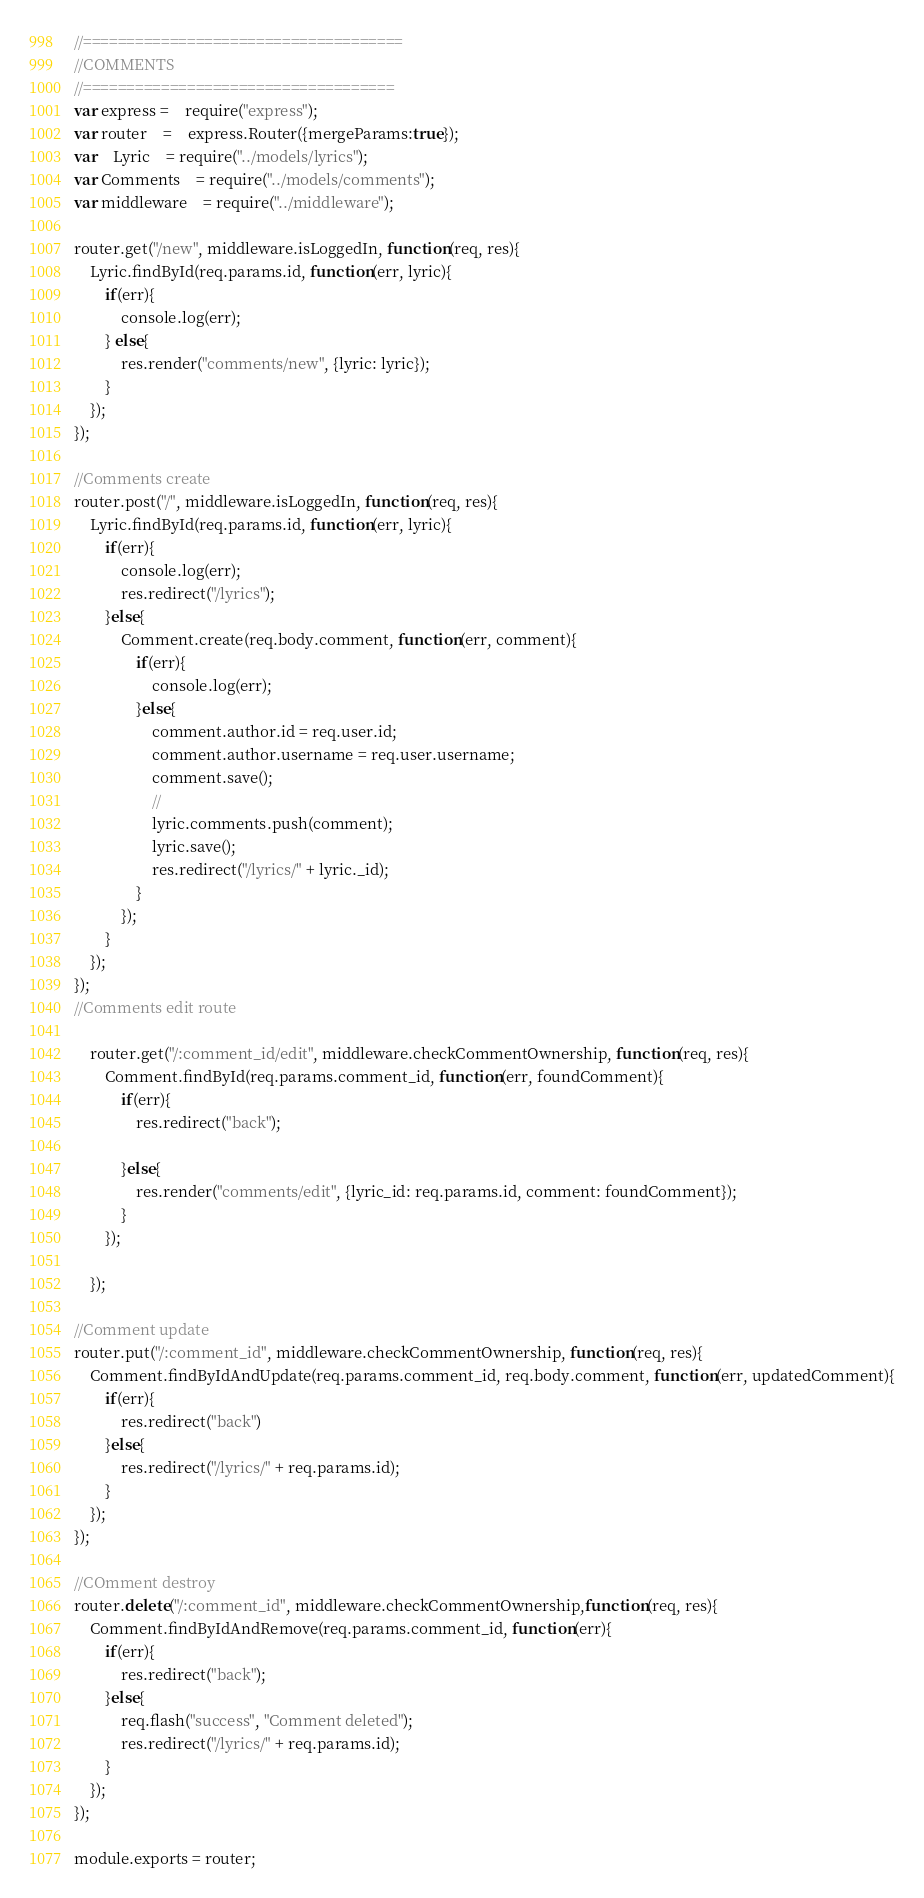<code> <loc_0><loc_0><loc_500><loc_500><_JavaScript_>//=====================================
//COMMENTS
//====================================
var express = 	require("express");
var router 	=	express.Router({mergeParams:true});
var	Lyric	= require("../models/lyrics");
var Comments 	= require("../models/comments");
var middleware	= require("../middleware");

router.get("/new", middleware.isLoggedIn, function(req, res){
	Lyric.findById(req.params.id, function(err, lyric){
		if(err){
			console.log(err);
		} else{
			res.render("comments/new", {lyric: lyric});
		}
	});
});

//Comments create
router.post("/", middleware.isLoggedIn, function(req, res){
	Lyric.findById(req.params.id, function(err, lyric){
		if(err){
			console.log(err);
			res.redirect("/lyrics");
		}else{
			Comment.create(req.body.comment, function(err, comment){
				if(err){
					console.log(err);
				}else{
					comment.author.id = req.user.id;
					comment.author.username = req.user.username;
					comment.save();
					//
					lyric.comments.push(comment);
					lyric.save();
					res.redirect("/lyrics/" + lyric._id);
				}
			});
		}
	});
});
//Comments edit route

	router.get("/:comment_id/edit", middleware.checkCommentOwnership, function(req, res){
		Comment.findById(req.params.comment_id, function(err, foundComment){
			if(err){
				res.redirect("back");

			}else{
				res.render("comments/edit", {lyric_id: req.params.id, comment: foundComment});
			}
		});

	});

//Comment update	
router.put("/:comment_id", middleware.checkCommentOwnership, function(req, res){
	Comment.findByIdAndUpdate(req.params.comment_id, req.body.comment, function(err, updatedComment){
		if(err){
			res.redirect("back")
		}else{
			res.redirect("/lyrics/" + req.params.id);
		}
	});
});

//COmment destroy 
router.delete("/:comment_id", middleware.checkCommentOwnership,function(req, res){
    Comment.findByIdAndRemove(req.params.comment_id, function(err){
        if(err){
            res.redirect("back");
        }else{
            req.flash("success", "Comment deleted");
            res.redirect("/lyrics/" + req.params.id);
        }
    });
});

module.exports = router;</code> 